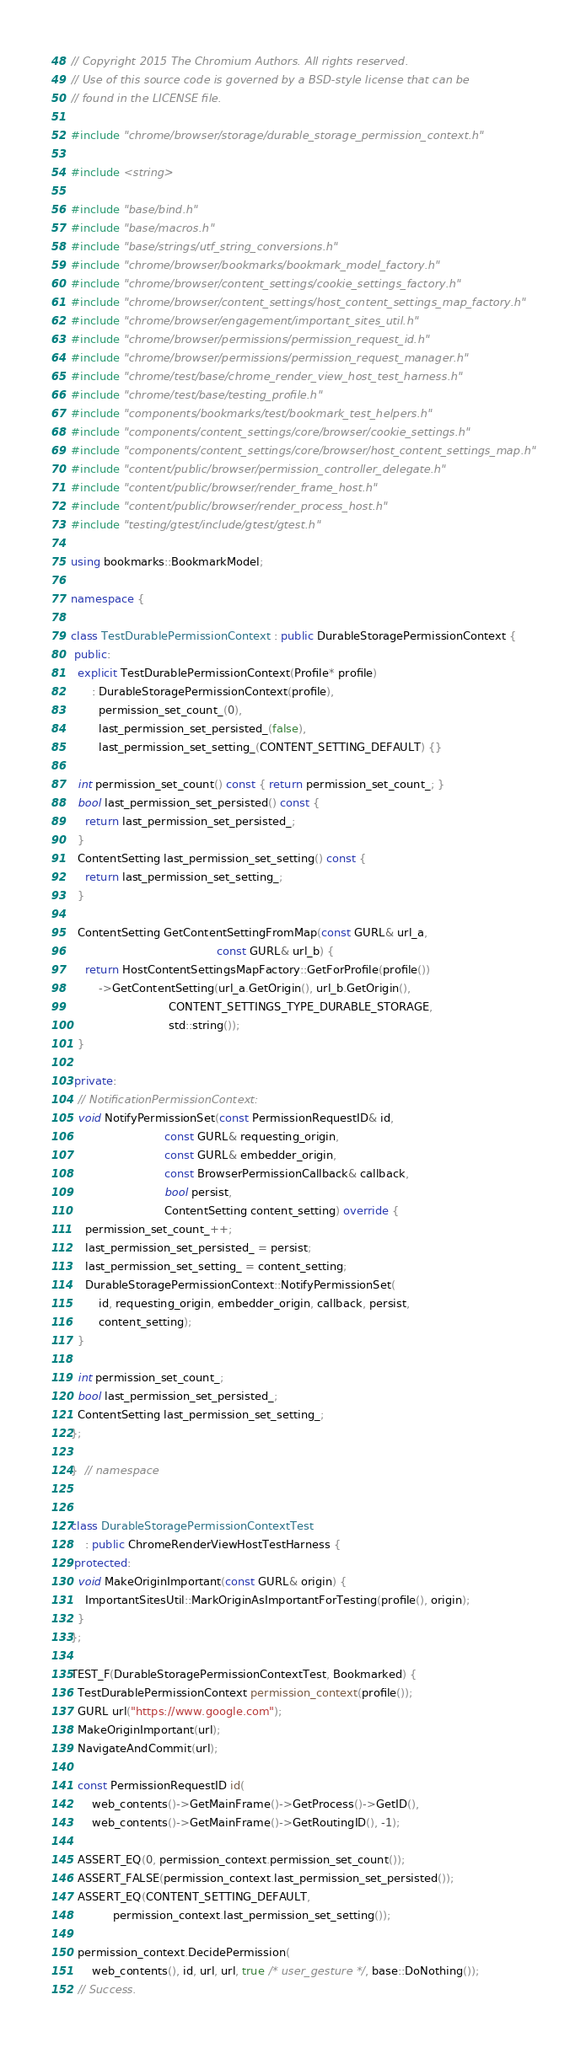<code> <loc_0><loc_0><loc_500><loc_500><_C++_>// Copyright 2015 The Chromium Authors. All rights reserved.
// Use of this source code is governed by a BSD-style license that can be
// found in the LICENSE file.

#include "chrome/browser/storage/durable_storage_permission_context.h"

#include <string>

#include "base/bind.h"
#include "base/macros.h"
#include "base/strings/utf_string_conversions.h"
#include "chrome/browser/bookmarks/bookmark_model_factory.h"
#include "chrome/browser/content_settings/cookie_settings_factory.h"
#include "chrome/browser/content_settings/host_content_settings_map_factory.h"
#include "chrome/browser/engagement/important_sites_util.h"
#include "chrome/browser/permissions/permission_request_id.h"
#include "chrome/browser/permissions/permission_request_manager.h"
#include "chrome/test/base/chrome_render_view_host_test_harness.h"
#include "chrome/test/base/testing_profile.h"
#include "components/bookmarks/test/bookmark_test_helpers.h"
#include "components/content_settings/core/browser/cookie_settings.h"
#include "components/content_settings/core/browser/host_content_settings_map.h"
#include "content/public/browser/permission_controller_delegate.h"
#include "content/public/browser/render_frame_host.h"
#include "content/public/browser/render_process_host.h"
#include "testing/gtest/include/gtest/gtest.h"

using bookmarks::BookmarkModel;

namespace {

class TestDurablePermissionContext : public DurableStoragePermissionContext {
 public:
  explicit TestDurablePermissionContext(Profile* profile)
      : DurableStoragePermissionContext(profile),
        permission_set_count_(0),
        last_permission_set_persisted_(false),
        last_permission_set_setting_(CONTENT_SETTING_DEFAULT) {}

  int permission_set_count() const { return permission_set_count_; }
  bool last_permission_set_persisted() const {
    return last_permission_set_persisted_;
  }
  ContentSetting last_permission_set_setting() const {
    return last_permission_set_setting_;
  }

  ContentSetting GetContentSettingFromMap(const GURL& url_a,
                                          const GURL& url_b) {
    return HostContentSettingsMapFactory::GetForProfile(profile())
        ->GetContentSetting(url_a.GetOrigin(), url_b.GetOrigin(),
                            CONTENT_SETTINGS_TYPE_DURABLE_STORAGE,
                            std::string());
  }

 private:
  // NotificationPermissionContext:
  void NotifyPermissionSet(const PermissionRequestID& id,
                           const GURL& requesting_origin,
                           const GURL& embedder_origin,
                           const BrowserPermissionCallback& callback,
                           bool persist,
                           ContentSetting content_setting) override {
    permission_set_count_++;
    last_permission_set_persisted_ = persist;
    last_permission_set_setting_ = content_setting;
    DurableStoragePermissionContext::NotifyPermissionSet(
        id, requesting_origin, embedder_origin, callback, persist,
        content_setting);
  }

  int permission_set_count_;
  bool last_permission_set_persisted_;
  ContentSetting last_permission_set_setting_;
};

}  // namespace


class DurableStoragePermissionContextTest
    : public ChromeRenderViewHostTestHarness {
 protected:
  void MakeOriginImportant(const GURL& origin) {
    ImportantSitesUtil::MarkOriginAsImportantForTesting(profile(), origin);
  }
};

TEST_F(DurableStoragePermissionContextTest, Bookmarked) {
  TestDurablePermissionContext permission_context(profile());
  GURL url("https://www.google.com");
  MakeOriginImportant(url);
  NavigateAndCommit(url);

  const PermissionRequestID id(
      web_contents()->GetMainFrame()->GetProcess()->GetID(),
      web_contents()->GetMainFrame()->GetRoutingID(), -1);

  ASSERT_EQ(0, permission_context.permission_set_count());
  ASSERT_FALSE(permission_context.last_permission_set_persisted());
  ASSERT_EQ(CONTENT_SETTING_DEFAULT,
            permission_context.last_permission_set_setting());

  permission_context.DecidePermission(
      web_contents(), id, url, url, true /* user_gesture */, base::DoNothing());
  // Success.</code> 